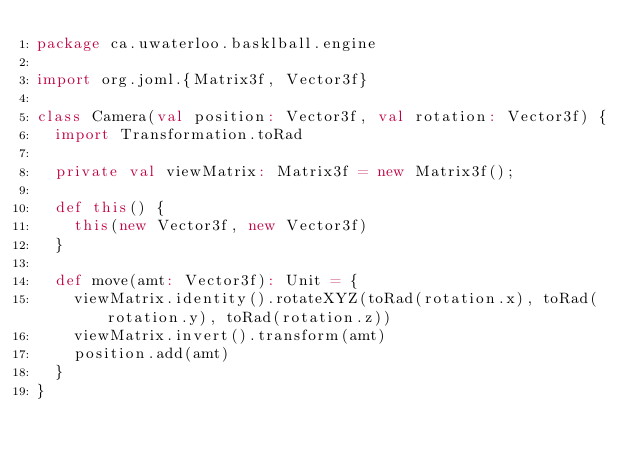<code> <loc_0><loc_0><loc_500><loc_500><_Scala_>package ca.uwaterloo.basklball.engine

import org.joml.{Matrix3f, Vector3f}

class Camera(val position: Vector3f, val rotation: Vector3f) {
  import Transformation.toRad

  private val viewMatrix: Matrix3f = new Matrix3f();

  def this() {
    this(new Vector3f, new Vector3f)
  }

  def move(amt: Vector3f): Unit = {
    viewMatrix.identity().rotateXYZ(toRad(rotation.x), toRad(rotation.y), toRad(rotation.z))
    viewMatrix.invert().transform(amt)
    position.add(amt)
  }
}
</code> 